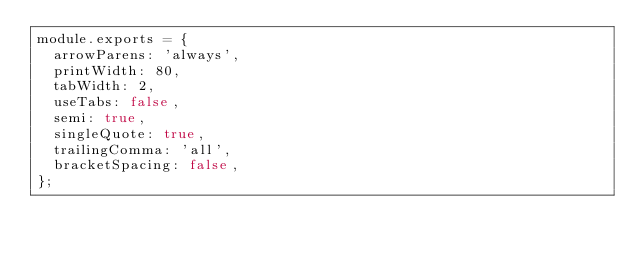Convert code to text. <code><loc_0><loc_0><loc_500><loc_500><_JavaScript_>module.exports = {
  arrowParens: 'always',
  printWidth: 80,
  tabWidth: 2,
  useTabs: false,
  semi: true,
  singleQuote: true,
  trailingComma: 'all',
  bracketSpacing: false,
};
</code> 